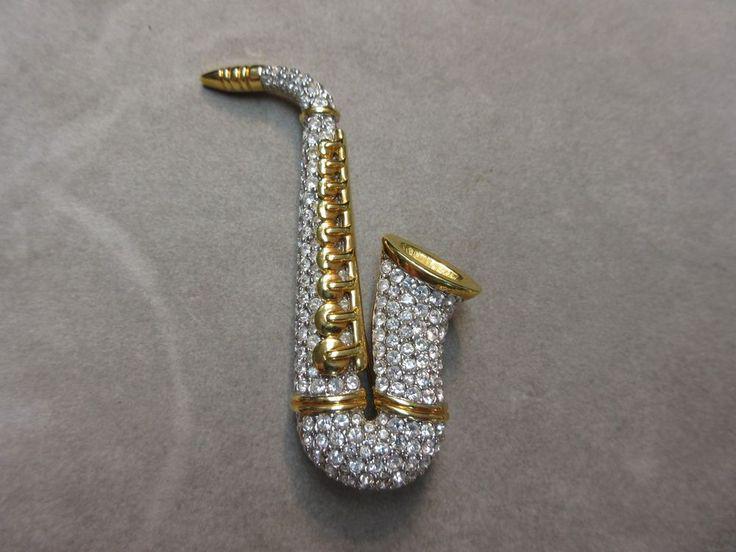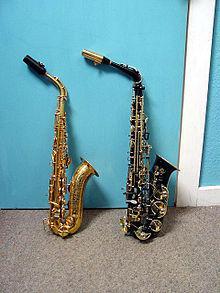The first image is the image on the left, the second image is the image on the right. Given the left and right images, does the statement "At least one image contains exactly three saxophones, and no image shows a saxophone broken down into parts." hold true? Answer yes or no. No. The first image is the image on the left, the second image is the image on the right. For the images shown, is this caption "In one image, exactly three saxophones are the same metallic color, but are different sizes and have different types of mouthpieces." true? Answer yes or no. No. 